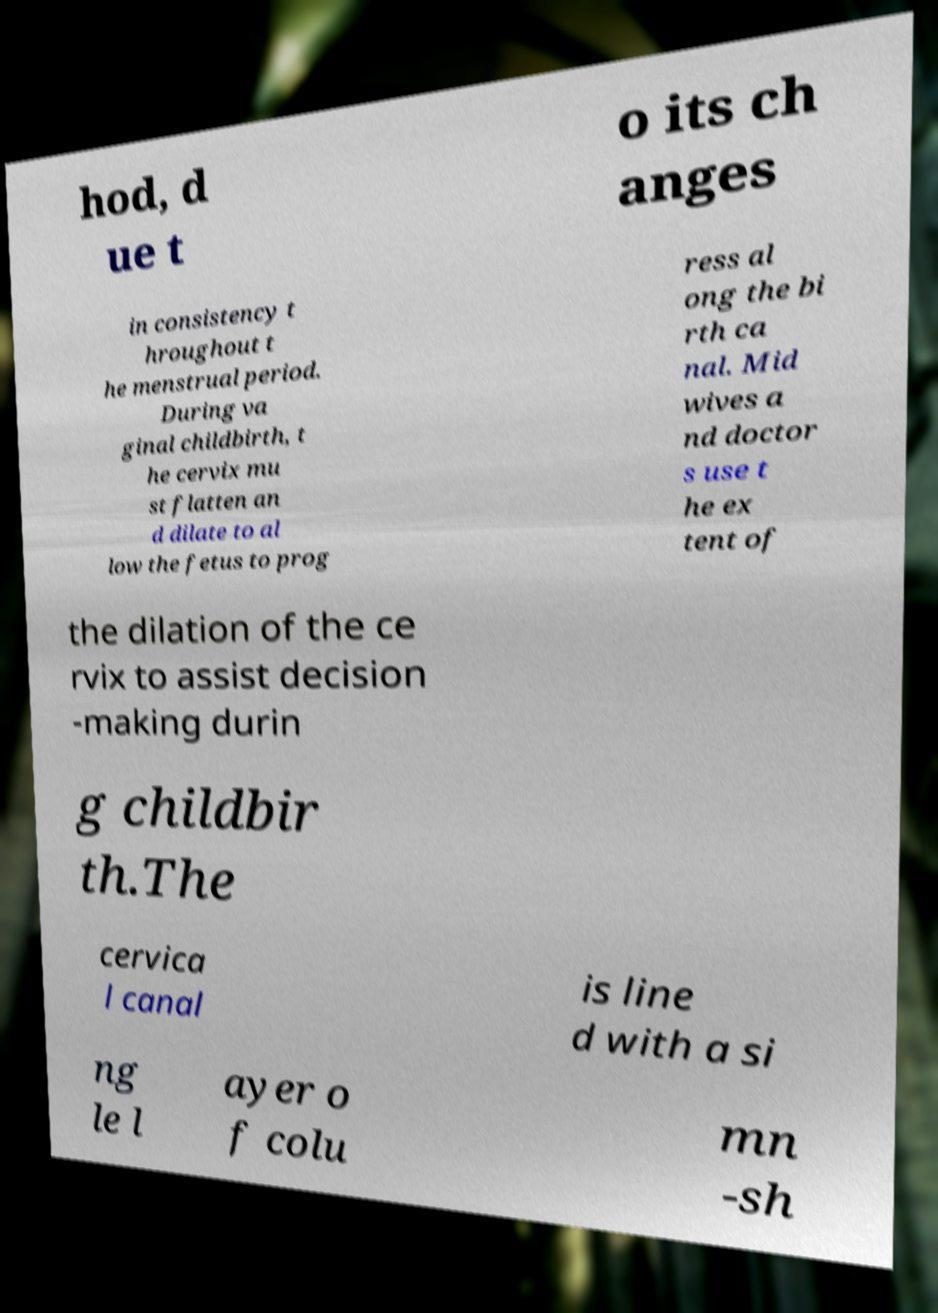Could you extract and type out the text from this image? hod, d ue t o its ch anges in consistency t hroughout t he menstrual period. During va ginal childbirth, t he cervix mu st flatten an d dilate to al low the fetus to prog ress al ong the bi rth ca nal. Mid wives a nd doctor s use t he ex tent of the dilation of the ce rvix to assist decision -making durin g childbir th.The cervica l canal is line d with a si ng le l ayer o f colu mn -sh 